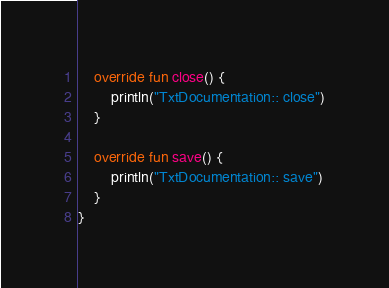<code> <loc_0><loc_0><loc_500><loc_500><_Kotlin_>
    override fun close() {
        println("TxtDocumentation:: close")
    }

    override fun save() {
        println("TxtDocumentation:: save")
    }
}
</code> 